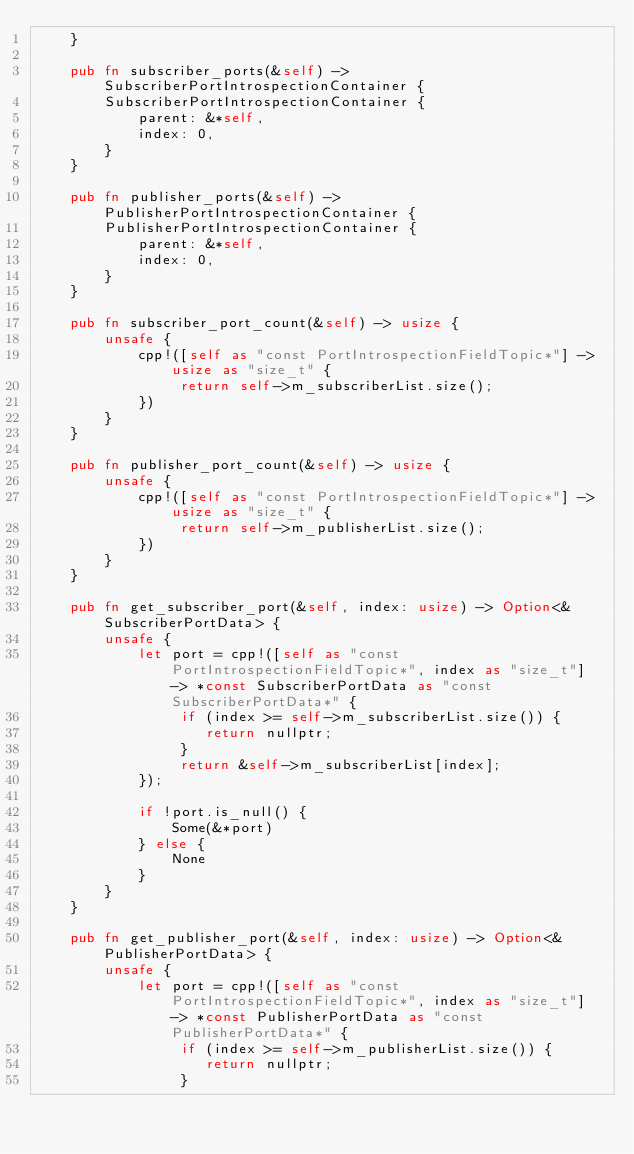Convert code to text. <code><loc_0><loc_0><loc_500><loc_500><_Rust_>    }

    pub fn subscriber_ports(&self) -> SubscriberPortIntrospectionContainer {
        SubscriberPortIntrospectionContainer {
            parent: &*self,
            index: 0,
        }
    }

    pub fn publisher_ports(&self) -> PublisherPortIntrospectionContainer {
        PublisherPortIntrospectionContainer {
            parent: &*self,
            index: 0,
        }
    }

    pub fn subscriber_port_count(&self) -> usize {
        unsafe {
            cpp!([self as "const PortIntrospectionFieldTopic*"] -> usize as "size_t" {
                 return self->m_subscriberList.size();
            })
        }
    }

    pub fn publisher_port_count(&self) -> usize {
        unsafe {
            cpp!([self as "const PortIntrospectionFieldTopic*"] -> usize as "size_t" {
                 return self->m_publisherList.size();
            })
        }
    }

    pub fn get_subscriber_port(&self, index: usize) -> Option<&SubscriberPortData> {
        unsafe {
            let port = cpp!([self as "const PortIntrospectionFieldTopic*", index as "size_t"] -> *const SubscriberPortData as "const SubscriberPortData*" {
                 if (index >= self->m_subscriberList.size()) {
                    return nullptr;
                 }
                 return &self->m_subscriberList[index];
            });

            if !port.is_null() {
                Some(&*port)
            } else {
                None
            }
        }
    }

    pub fn get_publisher_port(&self, index: usize) -> Option<&PublisherPortData> {
        unsafe {
            let port = cpp!([self as "const PortIntrospectionFieldTopic*", index as "size_t"] -> *const PublisherPortData as "const PublisherPortData*" {
                 if (index >= self->m_publisherList.size()) {
                    return nullptr;
                 }</code> 